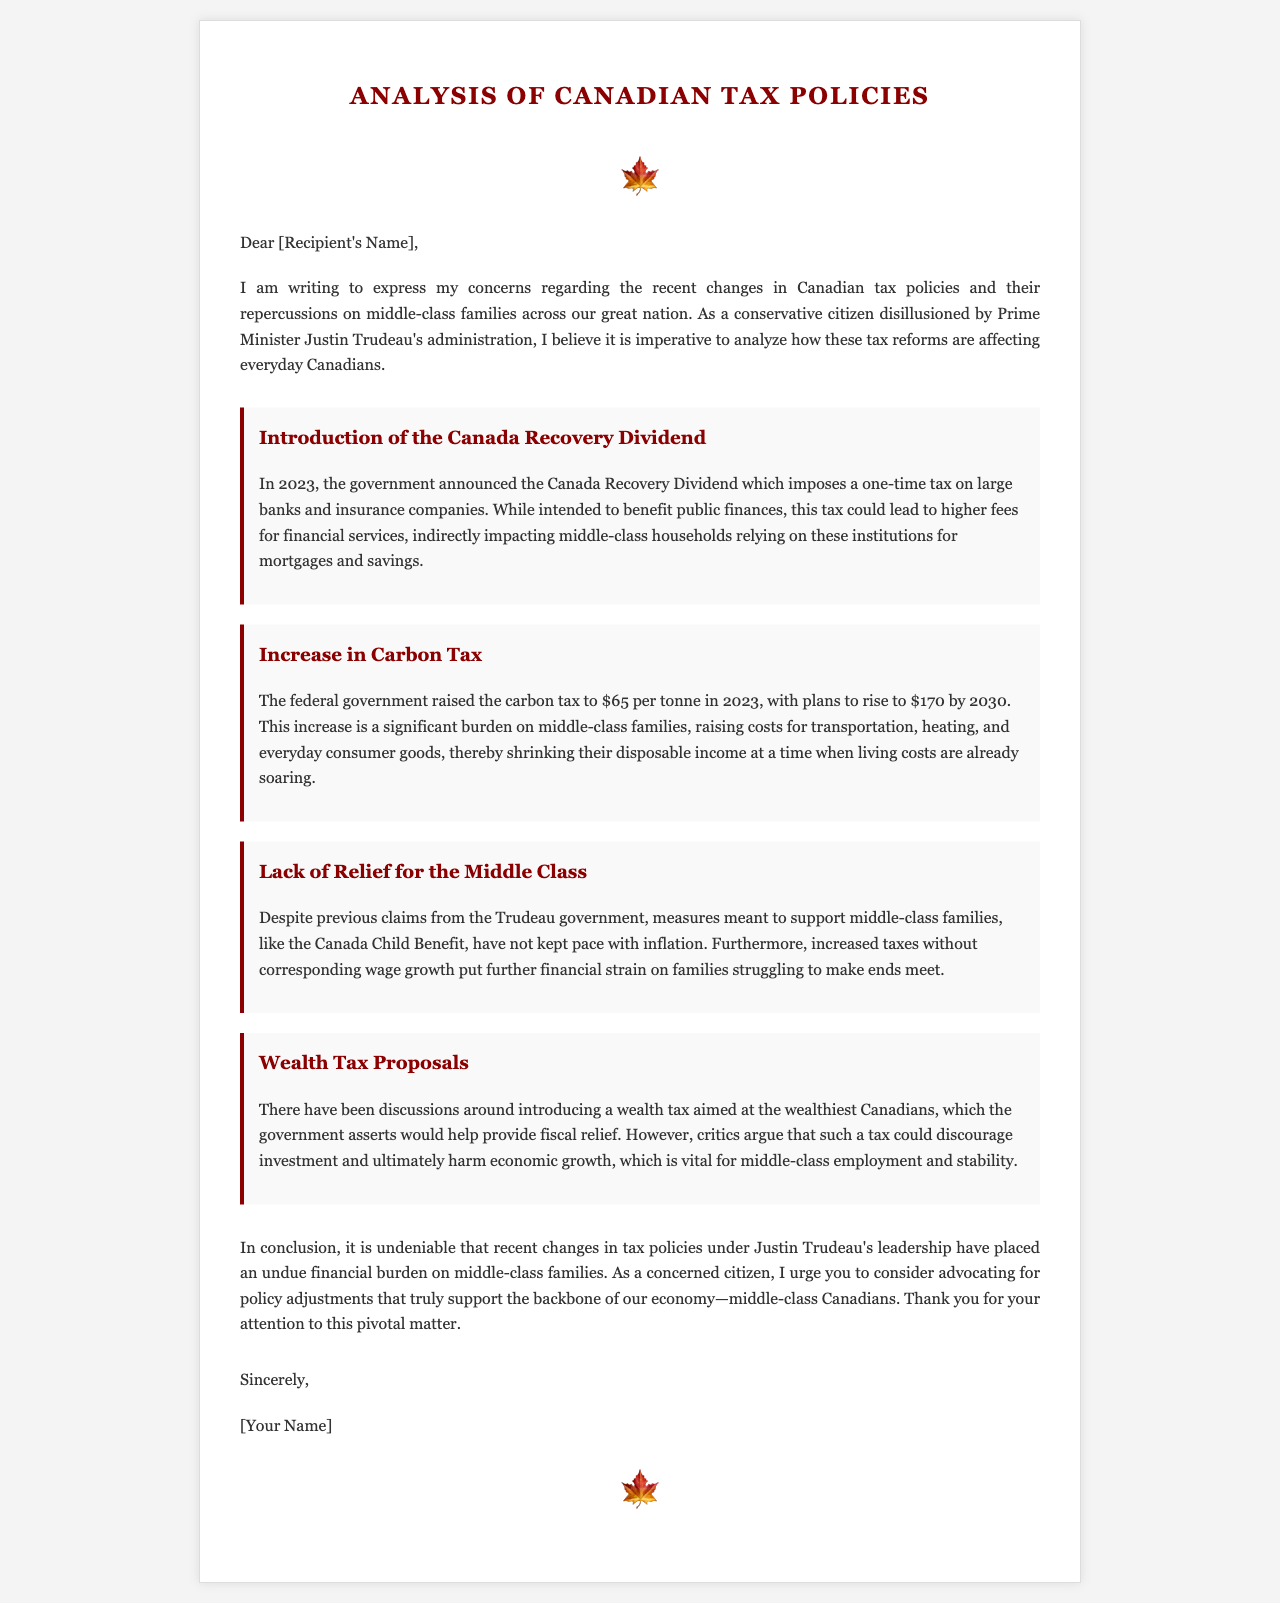what is the title of the document? The title is presented prominently at the top of the document.
Answer: Analysis of Canadian Tax Policies who is the intended recipient of the letter? The letter is addressed to an unspecified person indicated by [Recipient's Name].
Answer: [Recipient's Name] what year was the Canada Recovery Dividend announced? The letter specifies the announcement year of the Canada Recovery Dividend.
Answer: 2023 what is the initial carbon tax rate mentioned? The letter states the starting carbon tax rate in 2023.
Answer: $65 per tonne what is the projected carbon tax rate by 2030? The letter provides information about future plans for the carbon tax.
Answer: $170 which benefit has not kept pace with inflation? The letter mentions a specific benefit that has lagged behind inflation.
Answer: Canada Child Benefit what is the primary concern regarding the proposed wealth tax? The document discusses potential adverse effects of the wealth tax.
Answer: Discourage investment what does the author urge for in terms of policy? The author requests specific support for a certain demographic.
Answer: Policy adjustments who is expressing concerns in the letter? The letter is written from the perspective of a specific type of citizen.
Answer: A conservative citizen 